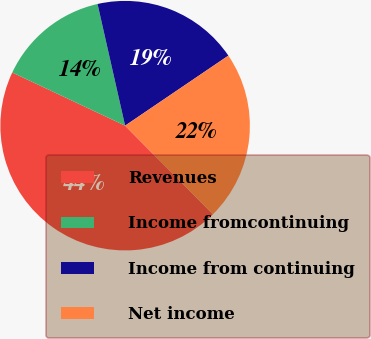<chart> <loc_0><loc_0><loc_500><loc_500><pie_chart><fcel>Revenues<fcel>Income fromcontinuing<fcel>Income from continuing<fcel>Net income<nl><fcel>44.43%<fcel>14.45%<fcel>19.06%<fcel>22.06%<nl></chart> 